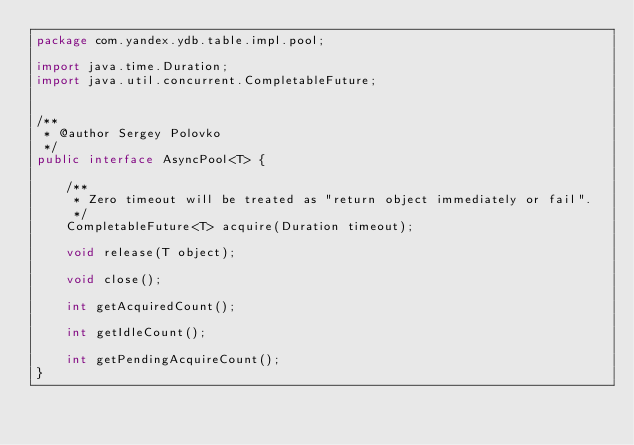<code> <loc_0><loc_0><loc_500><loc_500><_Java_>package com.yandex.ydb.table.impl.pool;

import java.time.Duration;
import java.util.concurrent.CompletableFuture;


/**
 * @author Sergey Polovko
 */
public interface AsyncPool<T> {

    /**
     * Zero timeout will be treated as "return object immediately or fail".
     */
    CompletableFuture<T> acquire(Duration timeout);

    void release(T object);

    void close();

    int getAcquiredCount();

    int getIdleCount();

    int getPendingAcquireCount();
}
</code> 